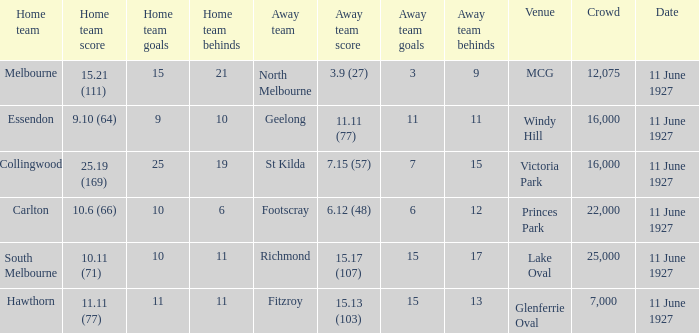Which home team competed against the away team Geelong? Essendon. 